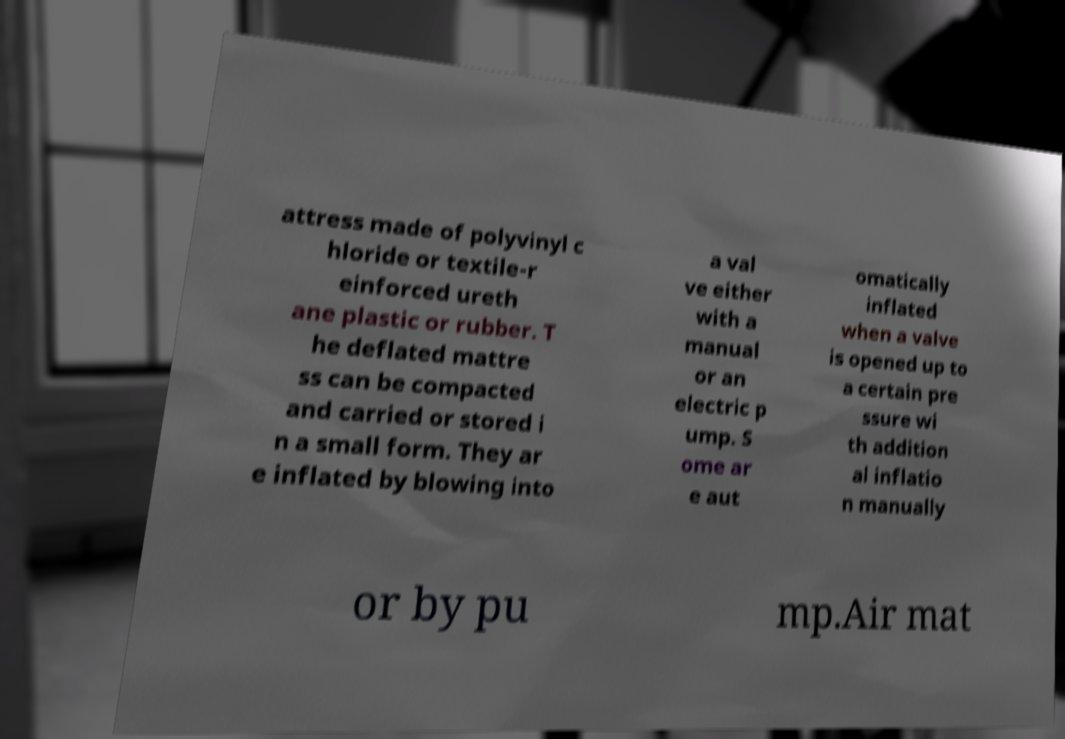I need the written content from this picture converted into text. Can you do that? attress made of polyvinyl c hloride or textile-r einforced ureth ane plastic or rubber. T he deflated mattre ss can be compacted and carried or stored i n a small form. They ar e inflated by blowing into a val ve either with a manual or an electric p ump. S ome ar e aut omatically inflated when a valve is opened up to a certain pre ssure wi th addition al inflatio n manually or by pu mp.Air mat 